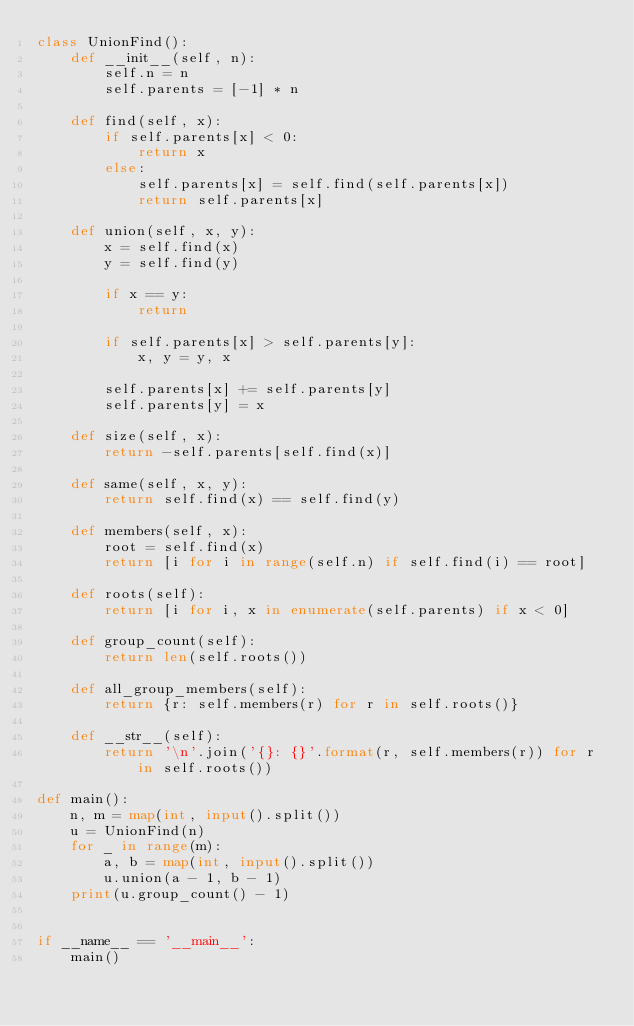<code> <loc_0><loc_0><loc_500><loc_500><_Python_>class UnionFind():
    def __init__(self, n):
        self.n = n
        self.parents = [-1] * n

    def find(self, x):
        if self.parents[x] < 0:
            return x
        else:
            self.parents[x] = self.find(self.parents[x])
            return self.parents[x]

    def union(self, x, y):
        x = self.find(x)
        y = self.find(y)

        if x == y:
            return

        if self.parents[x] > self.parents[y]:
            x, y = y, x

        self.parents[x] += self.parents[y]
        self.parents[y] = x

    def size(self, x):
        return -self.parents[self.find(x)]

    def same(self, x, y):
        return self.find(x) == self.find(y)

    def members(self, x):
        root = self.find(x)
        return [i for i in range(self.n) if self.find(i) == root]

    def roots(self):
        return [i for i, x in enumerate(self.parents) if x < 0]

    def group_count(self):
        return len(self.roots())

    def all_group_members(self):
        return {r: self.members(r) for r in self.roots()}

    def __str__(self):
        return '\n'.join('{}: {}'.format(r, self.members(r)) for r in self.roots())

def main():
    n, m = map(int, input().split())
    u = UnionFind(n)
    for _ in range(m):
        a, b = map(int, input().split())
        u.union(a - 1, b - 1)
    print(u.group_count() - 1)
    
        
if __name__ == '__main__':
    main()
</code> 